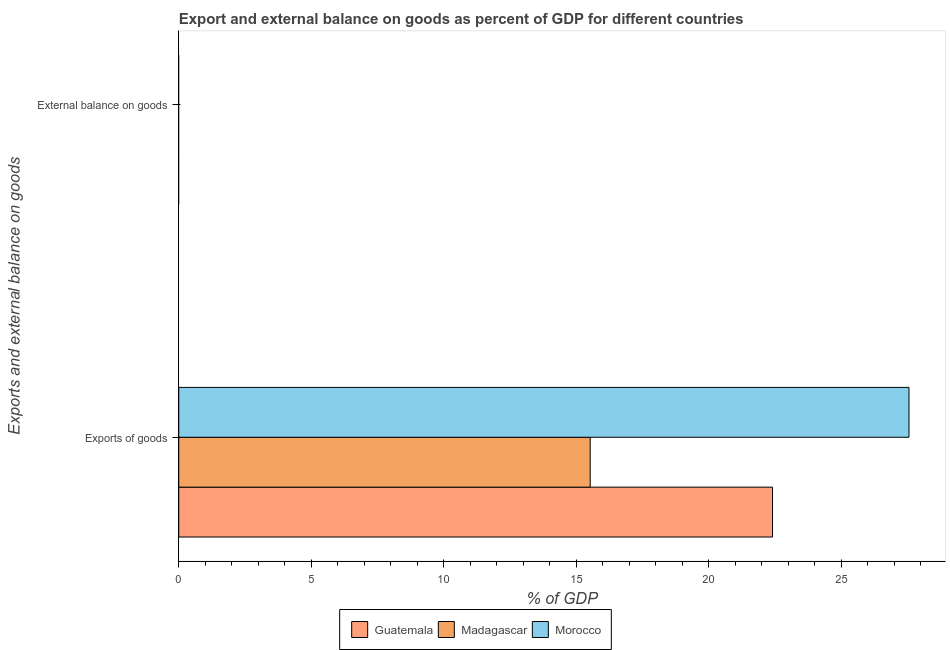How many different coloured bars are there?
Keep it short and to the point. 3. Are the number of bars on each tick of the Y-axis equal?
Keep it short and to the point. No. How many bars are there on the 1st tick from the top?
Give a very brief answer. 0. How many bars are there on the 1st tick from the bottom?
Provide a succinct answer. 3. What is the label of the 1st group of bars from the top?
Your answer should be compact. External balance on goods. What is the external balance on goods as percentage of gdp in Guatemala?
Your answer should be compact. 0. Across all countries, what is the maximum export of goods as percentage of gdp?
Your answer should be very brief. 27.56. In which country was the export of goods as percentage of gdp maximum?
Offer a very short reply. Morocco. What is the total export of goods as percentage of gdp in the graph?
Offer a very short reply. 65.49. What is the difference between the export of goods as percentage of gdp in Guatemala and that in Madagascar?
Your response must be concise. 6.88. What is the difference between the external balance on goods as percentage of gdp in Madagascar and the export of goods as percentage of gdp in Morocco?
Provide a succinct answer. -27.56. What is the average export of goods as percentage of gdp per country?
Make the answer very short. 21.83. In how many countries, is the export of goods as percentage of gdp greater than 25 %?
Provide a succinct answer. 1. What is the ratio of the export of goods as percentage of gdp in Morocco to that in Madagascar?
Provide a succinct answer. 1.77. Is the export of goods as percentage of gdp in Morocco less than that in Madagascar?
Make the answer very short. No. In how many countries, is the external balance on goods as percentage of gdp greater than the average external balance on goods as percentage of gdp taken over all countries?
Provide a short and direct response. 0. Are all the bars in the graph horizontal?
Your answer should be very brief. Yes. Are the values on the major ticks of X-axis written in scientific E-notation?
Make the answer very short. No. What is the title of the graph?
Offer a very short reply. Export and external balance on goods as percent of GDP for different countries. Does "Sub-Saharan Africa (all income levels)" appear as one of the legend labels in the graph?
Make the answer very short. No. What is the label or title of the X-axis?
Make the answer very short. % of GDP. What is the label or title of the Y-axis?
Your answer should be very brief. Exports and external balance on goods. What is the % of GDP in Guatemala in Exports of goods?
Provide a short and direct response. 22.41. What is the % of GDP of Madagascar in Exports of goods?
Make the answer very short. 15.53. What is the % of GDP of Morocco in Exports of goods?
Make the answer very short. 27.56. What is the % of GDP of Guatemala in External balance on goods?
Provide a short and direct response. 0. What is the % of GDP in Madagascar in External balance on goods?
Provide a short and direct response. 0. Across all Exports and external balance on goods, what is the maximum % of GDP in Guatemala?
Provide a short and direct response. 22.41. Across all Exports and external balance on goods, what is the maximum % of GDP of Madagascar?
Give a very brief answer. 15.53. Across all Exports and external balance on goods, what is the maximum % of GDP in Morocco?
Provide a short and direct response. 27.56. Across all Exports and external balance on goods, what is the minimum % of GDP of Guatemala?
Provide a short and direct response. 0. Across all Exports and external balance on goods, what is the minimum % of GDP of Madagascar?
Provide a succinct answer. 0. What is the total % of GDP in Guatemala in the graph?
Your answer should be very brief. 22.41. What is the total % of GDP of Madagascar in the graph?
Provide a short and direct response. 15.53. What is the total % of GDP in Morocco in the graph?
Give a very brief answer. 27.56. What is the average % of GDP in Guatemala per Exports and external balance on goods?
Provide a short and direct response. 11.2. What is the average % of GDP in Madagascar per Exports and external balance on goods?
Give a very brief answer. 7.76. What is the average % of GDP of Morocco per Exports and external balance on goods?
Your response must be concise. 13.78. What is the difference between the % of GDP of Guatemala and % of GDP of Madagascar in Exports of goods?
Ensure brevity in your answer.  6.88. What is the difference between the % of GDP of Guatemala and % of GDP of Morocco in Exports of goods?
Offer a very short reply. -5.15. What is the difference between the % of GDP in Madagascar and % of GDP in Morocco in Exports of goods?
Give a very brief answer. -12.03. What is the difference between the highest and the lowest % of GDP in Guatemala?
Offer a terse response. 22.41. What is the difference between the highest and the lowest % of GDP of Madagascar?
Make the answer very short. 15.53. What is the difference between the highest and the lowest % of GDP in Morocco?
Your answer should be very brief. 27.56. 